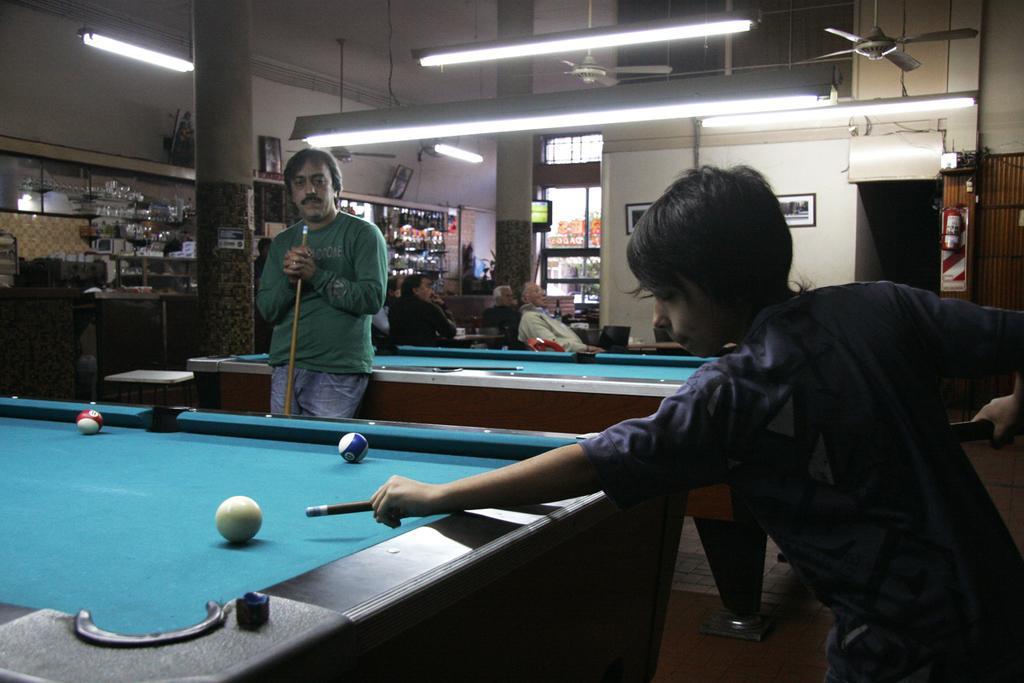Please provide a concise description of this image. This is an image clicked inside the room. Here I can see a boy playing the billiards game. He's about to hit the ball. Beside this table there is a man standing and looking at the game. On the top of the image there are lights. In the background I can see few people are sitting on the chairs. 